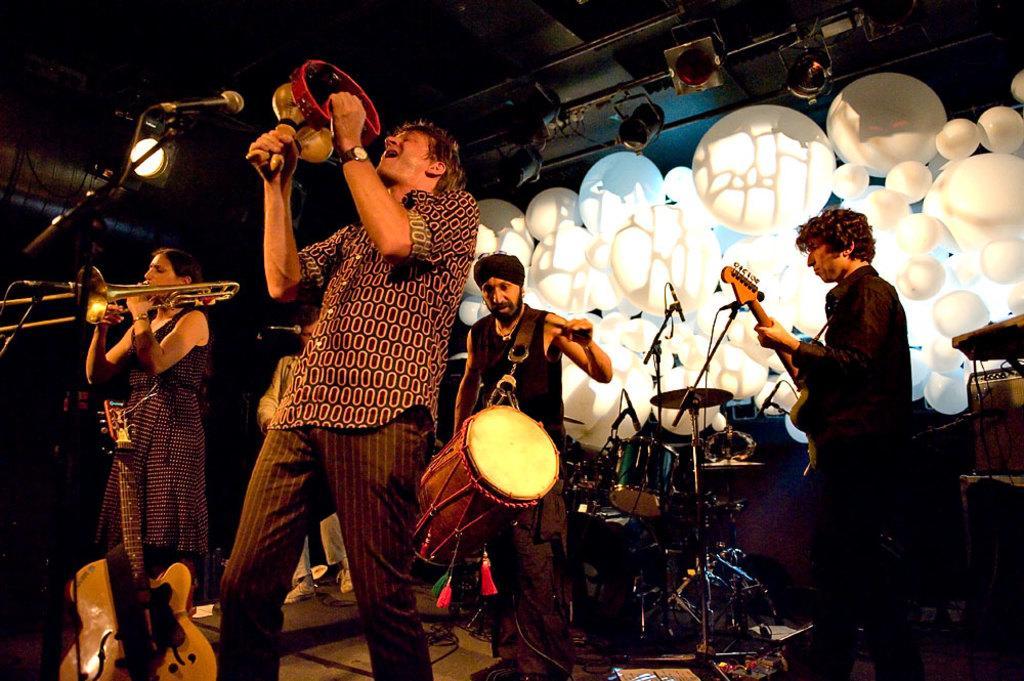Please provide a concise description of this image. In this picture we can see a man standing and singing, and in front here is the microphone, and at beside a woman is standing and playing music, and t back a man is standing and playing drums, and here a man is playing the guitar, and here are the musical drums. 